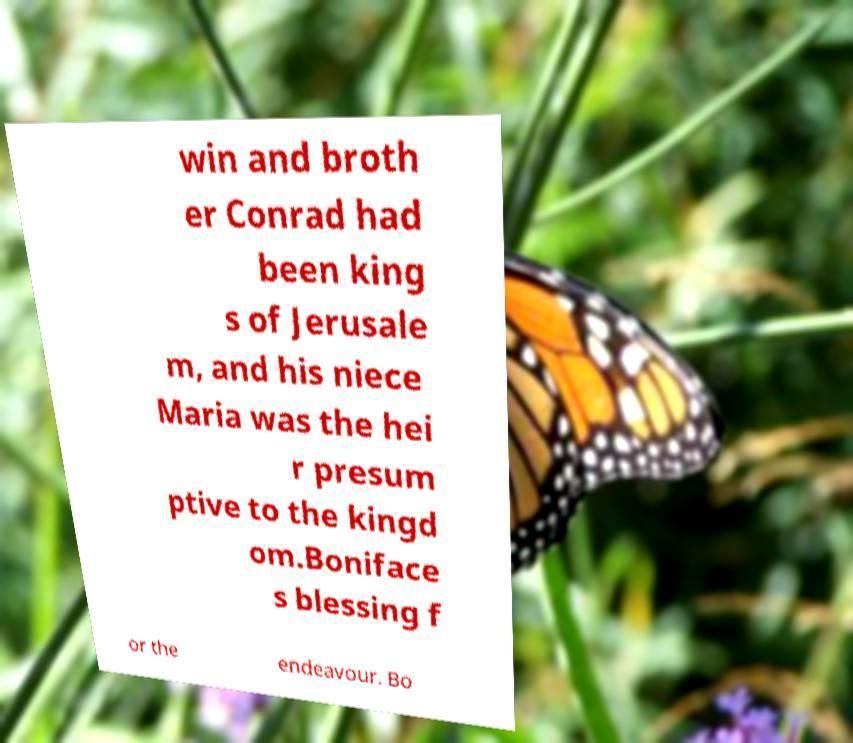I need the written content from this picture converted into text. Can you do that? win and broth er Conrad had been king s of Jerusale m, and his niece Maria was the hei r presum ptive to the kingd om.Boniface s blessing f or the endeavour. Bo 